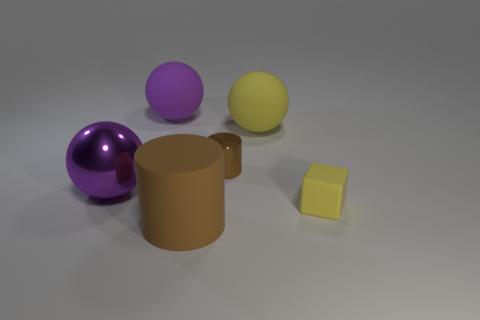There is a big ball that is the same color as the tiny rubber thing; what material is it?
Your answer should be very brief. Rubber. There is a big purple thing behind the small brown metallic object; does it have the same shape as the big purple shiny object?
Keep it short and to the point. Yes. Are there fewer shiny cylinders to the left of the metal cylinder than yellow matte blocks that are to the right of the big brown matte thing?
Make the answer very short. Yes. There is a brown thing that is behind the matte block; what is its material?
Your answer should be compact. Metal. There is a thing that is the same color as the big metallic ball; what size is it?
Ensure brevity in your answer.  Large. Are there any other gray metal spheres that have the same size as the shiny sphere?
Provide a short and direct response. No. There is a small brown thing; is its shape the same as the yellow rubber object that is behind the big shiny thing?
Keep it short and to the point. No. There is a rubber object that is on the left side of the large brown matte thing; does it have the same size as the yellow object that is in front of the purple metal thing?
Offer a very short reply. No. How many other things are there of the same shape as the big purple metal thing?
Ensure brevity in your answer.  2. There is a sphere that is on the right side of the matte object in front of the small block; what is it made of?
Your response must be concise. Rubber. 